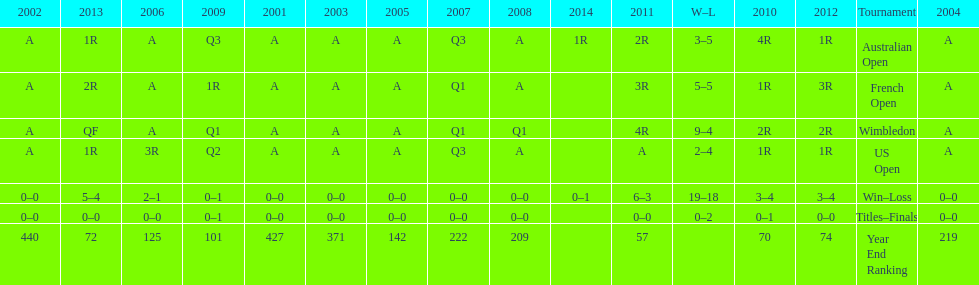In which year was the highest year-end ranking attained? 2011. 